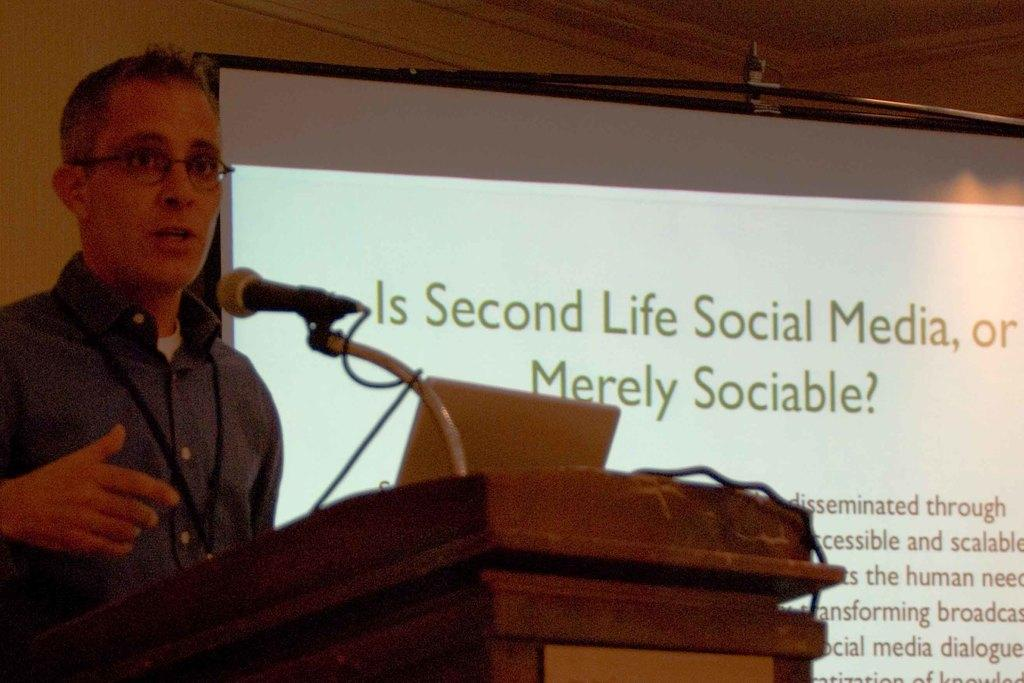What is the man in the image doing? The man is standing in front of a podium. What object is the man likely using to communicate with the audience? There is a microphone in the image, which the man might be using to amplify his voice. What device is visible on the podium? There is a laptop in the image, which the man might be using for his presentation. What can be seen in the background of the image? There is a projector screen in the background of the image. What type of order is being served at the meeting in the image? There is no meeting or order being served in the image; it only shows a man standing in front of a podium with a microphone and laptop. 